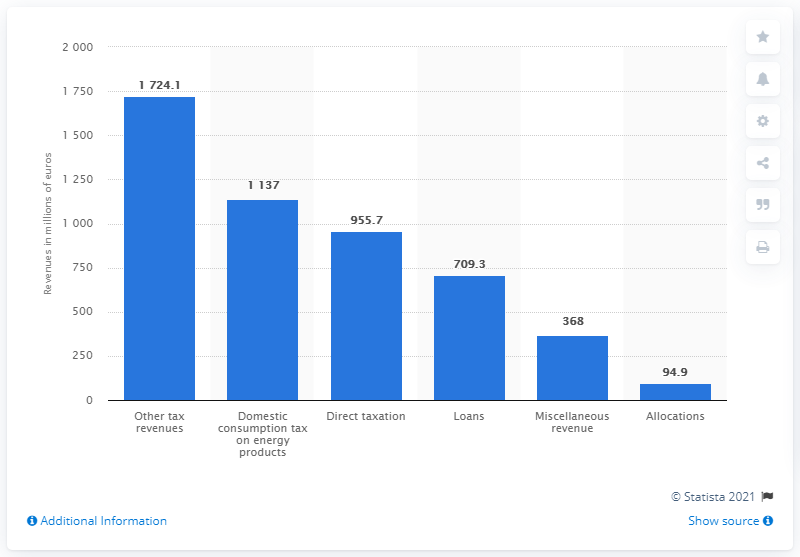Give some essential details in this illustration. In 2019, the Parisian region generated a total revenue of 955.7 million euros. 